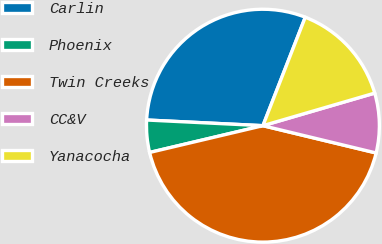<chart> <loc_0><loc_0><loc_500><loc_500><pie_chart><fcel>Carlin<fcel>Phoenix<fcel>Twin Creeks<fcel>CC&V<fcel>Yanacocha<nl><fcel>30.15%<fcel>4.47%<fcel>42.54%<fcel>8.28%<fcel>14.56%<nl></chart> 